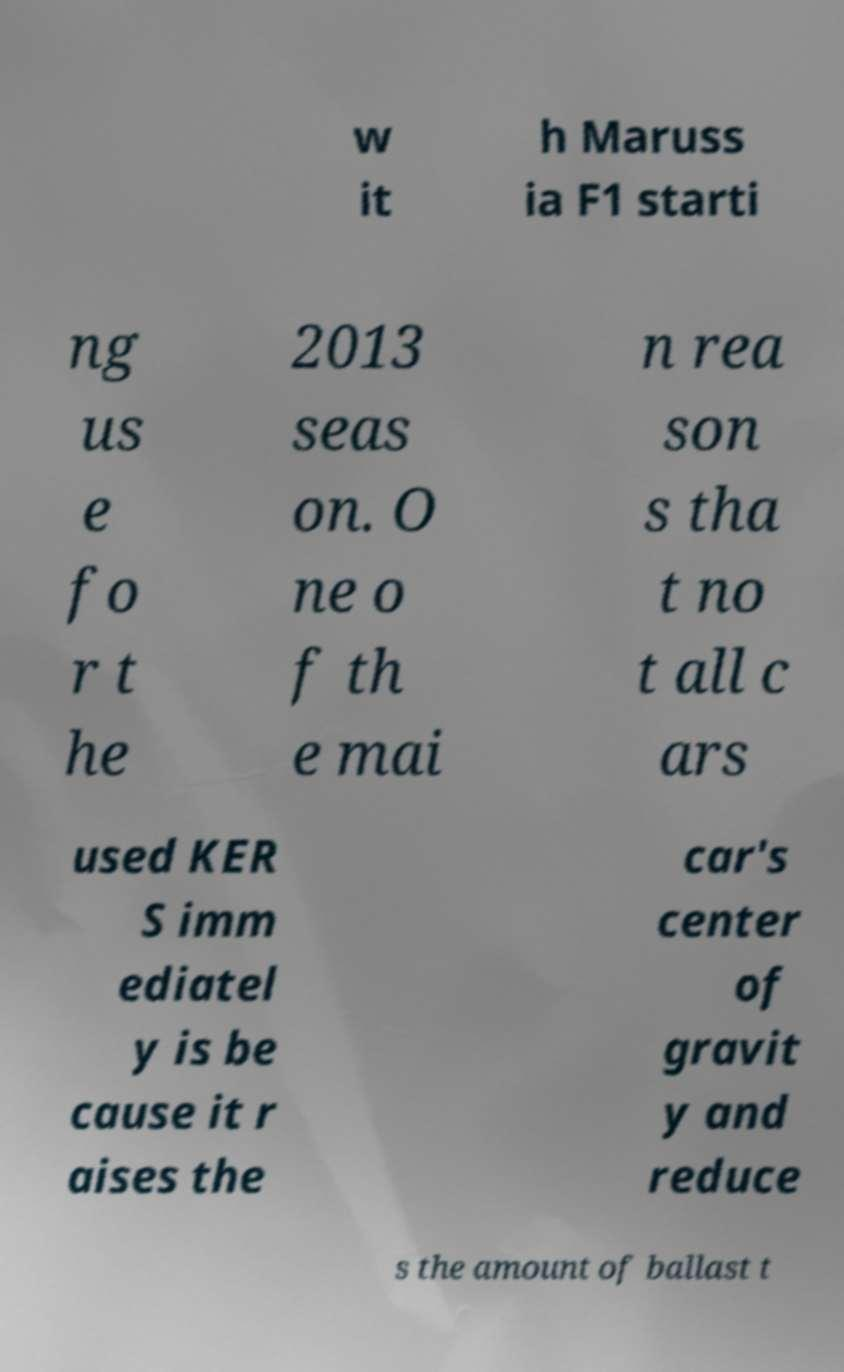I need the written content from this picture converted into text. Can you do that? w it h Maruss ia F1 starti ng us e fo r t he 2013 seas on. O ne o f th e mai n rea son s tha t no t all c ars used KER S imm ediatel y is be cause it r aises the car's center of gravit y and reduce s the amount of ballast t 